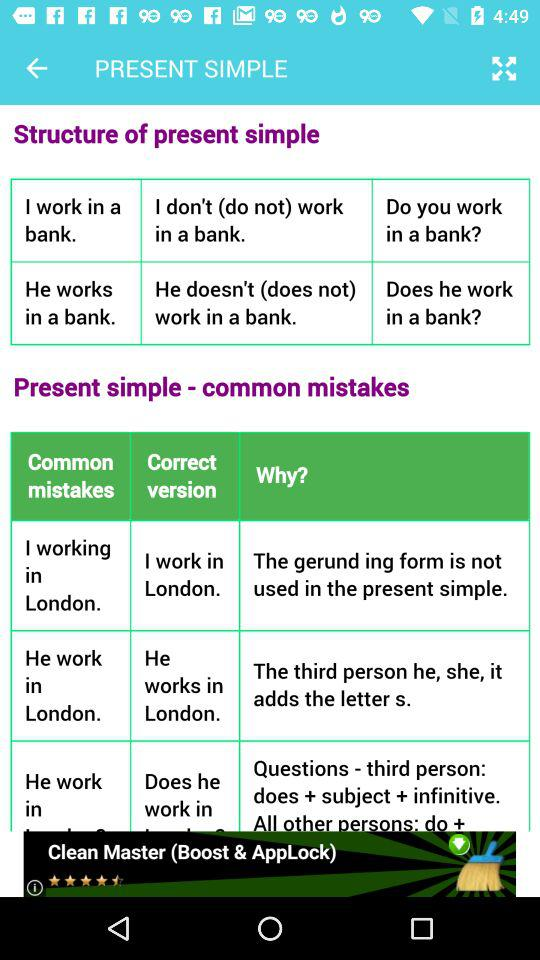How many common mistakes are there in the present simple?
Answer the question using a single word or phrase. 3 